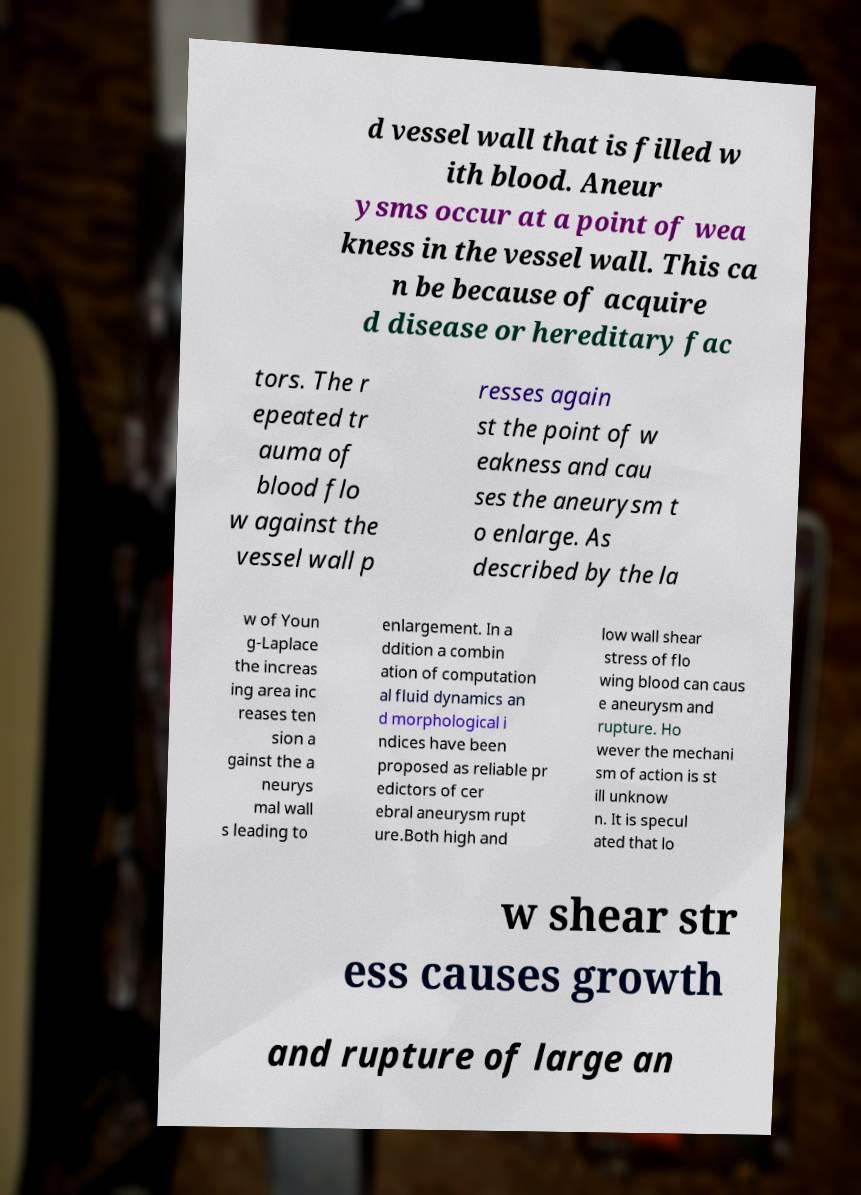Could you assist in decoding the text presented in this image and type it out clearly? d vessel wall that is filled w ith blood. Aneur ysms occur at a point of wea kness in the vessel wall. This ca n be because of acquire d disease or hereditary fac tors. The r epeated tr auma of blood flo w against the vessel wall p resses again st the point of w eakness and cau ses the aneurysm t o enlarge. As described by the la w of Youn g-Laplace the increas ing area inc reases ten sion a gainst the a neurys mal wall s leading to enlargement. In a ddition a combin ation of computation al fluid dynamics an d morphological i ndices have been proposed as reliable pr edictors of cer ebral aneurysm rupt ure.Both high and low wall shear stress of flo wing blood can caus e aneurysm and rupture. Ho wever the mechani sm of action is st ill unknow n. It is specul ated that lo w shear str ess causes growth and rupture of large an 